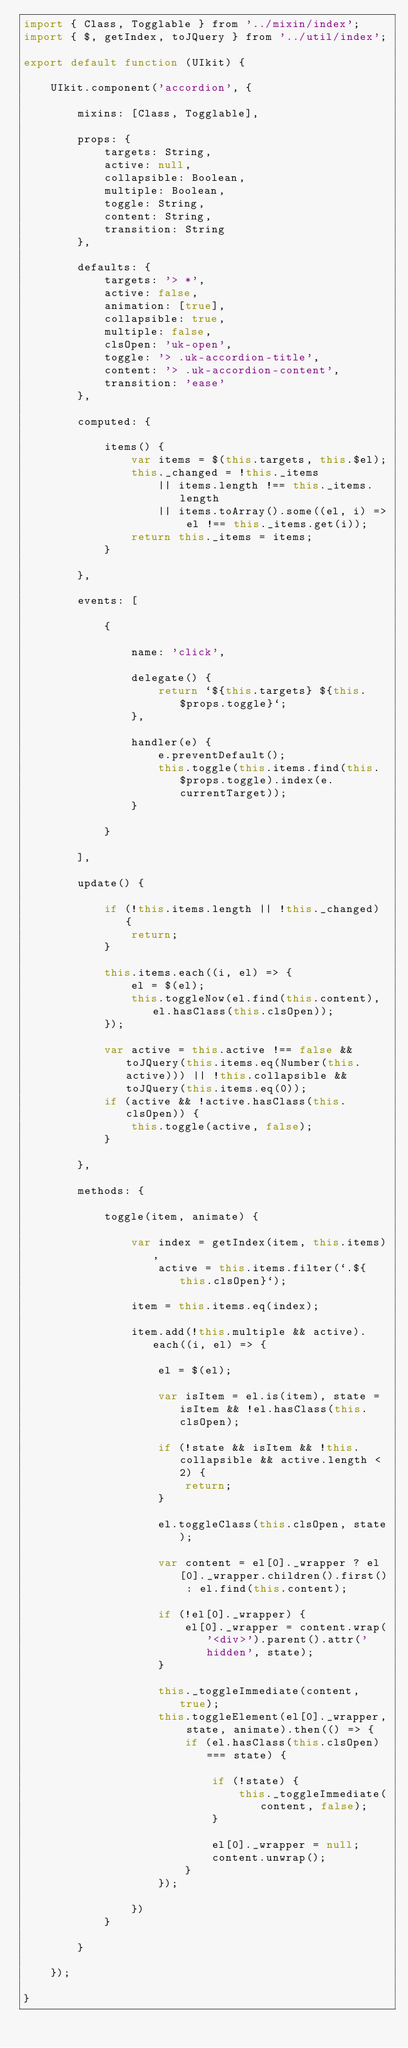Convert code to text. <code><loc_0><loc_0><loc_500><loc_500><_JavaScript_>import { Class, Togglable } from '../mixin/index';
import { $, getIndex, toJQuery } from '../util/index';

export default function (UIkit) {

    UIkit.component('accordion', {

        mixins: [Class, Togglable],

        props: {
            targets: String,
            active: null,
            collapsible: Boolean,
            multiple: Boolean,
            toggle: String,
            content: String,
            transition: String
        },

        defaults: {
            targets: '> *',
            active: false,
            animation: [true],
            collapsible: true,
            multiple: false,
            clsOpen: 'uk-open',
            toggle: '> .uk-accordion-title',
            content: '> .uk-accordion-content',
            transition: 'ease'
        },

        computed: {

            items() {
                var items = $(this.targets, this.$el);
                this._changed = !this._items
                    || items.length !== this._items.length
                    || items.toArray().some((el, i) => el !== this._items.get(i));
                return this._items = items;
            }

        },

        events: [

            {

                name: 'click',

                delegate() {
                    return `${this.targets} ${this.$props.toggle}`;
                },

                handler(e) {
                    e.preventDefault();
                    this.toggle(this.items.find(this.$props.toggle).index(e.currentTarget));
                }

            }

        ],

        update() {

            if (!this.items.length || !this._changed) {
                return;
            }

            this.items.each((i, el) => {
                el = $(el);
                this.toggleNow(el.find(this.content), el.hasClass(this.clsOpen));
            });

            var active = this.active !== false && toJQuery(this.items.eq(Number(this.active))) || !this.collapsible && toJQuery(this.items.eq(0));
            if (active && !active.hasClass(this.clsOpen)) {
                this.toggle(active, false);
            }

        },

        methods: {

            toggle(item, animate) {

                var index = getIndex(item, this.items),
                    active = this.items.filter(`.${this.clsOpen}`);

                item = this.items.eq(index);

                item.add(!this.multiple && active).each((i, el) => {

                    el = $(el);

                    var isItem = el.is(item), state = isItem && !el.hasClass(this.clsOpen);

                    if (!state && isItem && !this.collapsible && active.length < 2) {
                        return;
                    }

                    el.toggleClass(this.clsOpen, state);

                    var content = el[0]._wrapper ? el[0]._wrapper.children().first() : el.find(this.content);

                    if (!el[0]._wrapper) {
                        el[0]._wrapper = content.wrap('<div>').parent().attr('hidden', state);
                    }

                    this._toggleImmediate(content, true);
                    this.toggleElement(el[0]._wrapper, state, animate).then(() => {
                        if (el.hasClass(this.clsOpen) === state) {

                            if (!state) {
                                this._toggleImmediate(content, false);
                            }

                            el[0]._wrapper = null;
                            content.unwrap();
                        }
                    });

                })
            }

        }

    });

}
</code> 